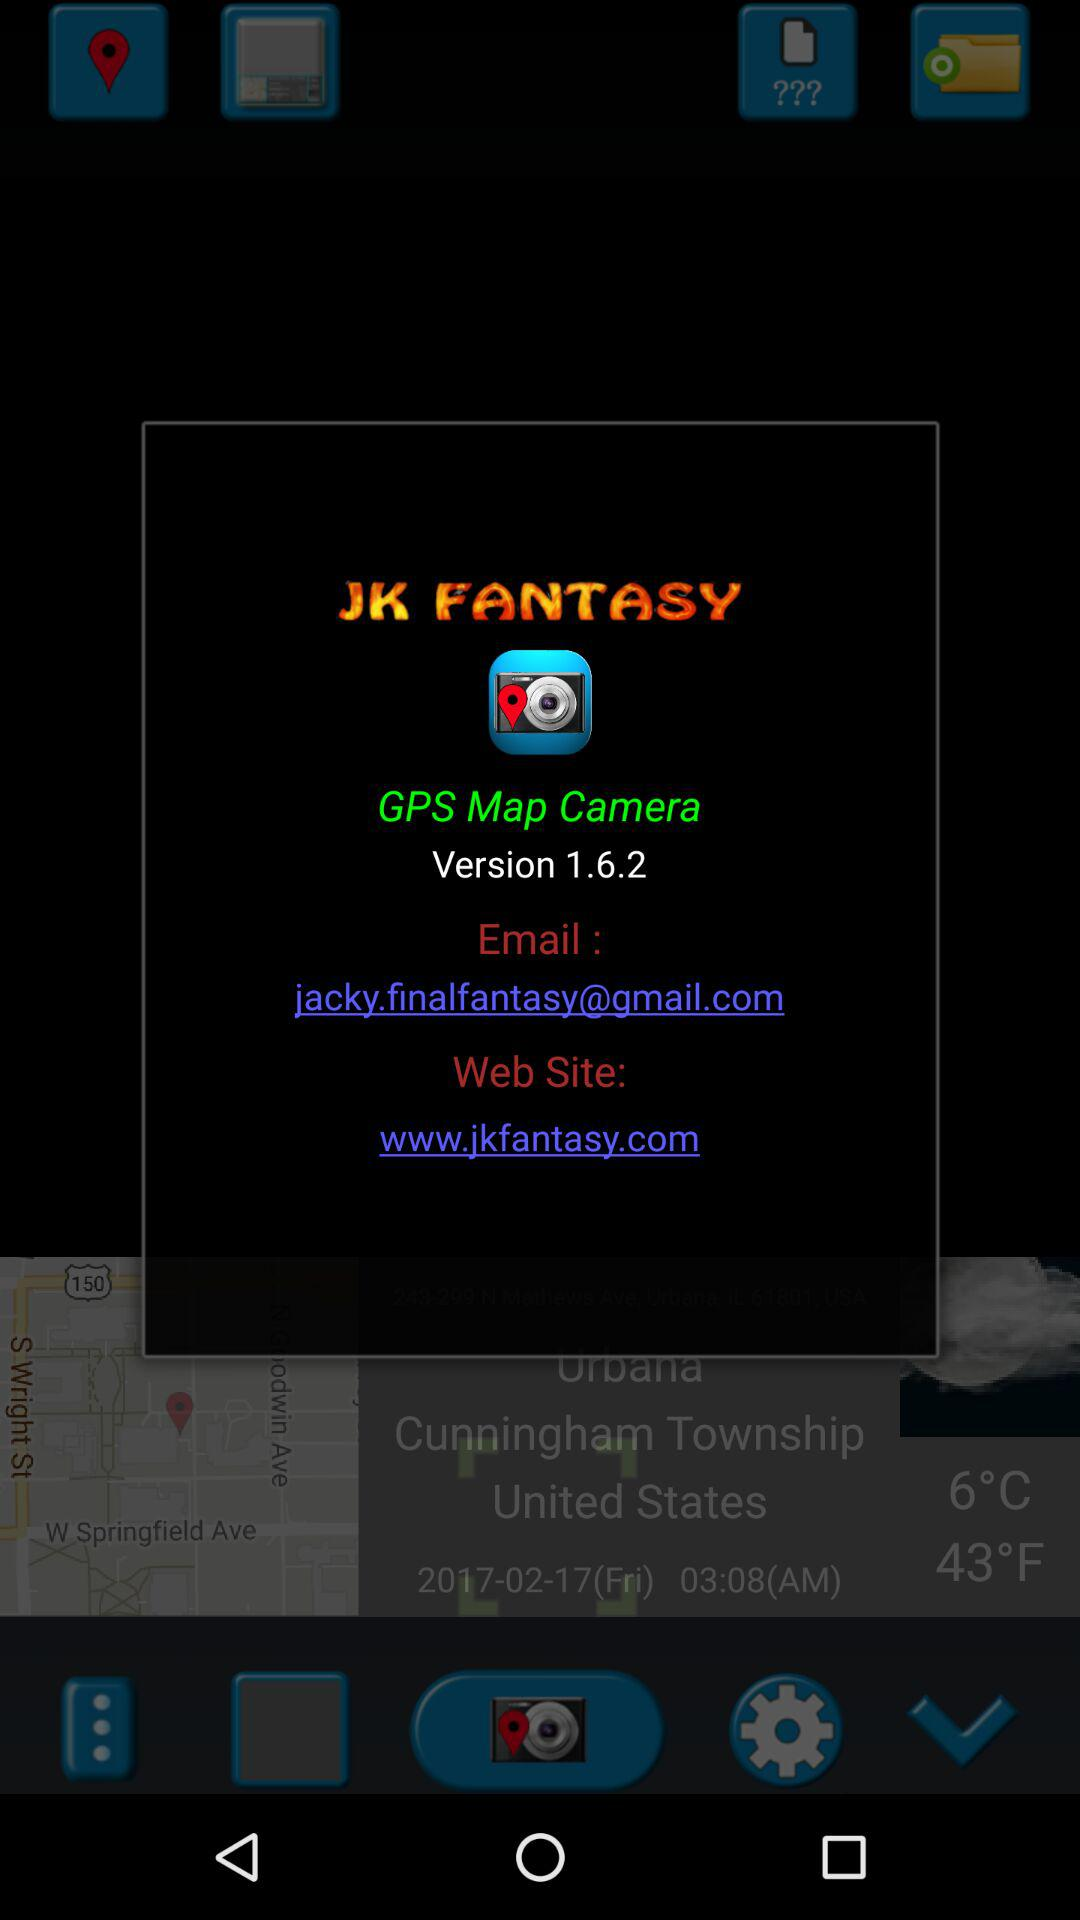On which website do we visit to open the "GPS Map Camera"? You should visit www.jkfantasy.com to open the "GPS Map Camera". 